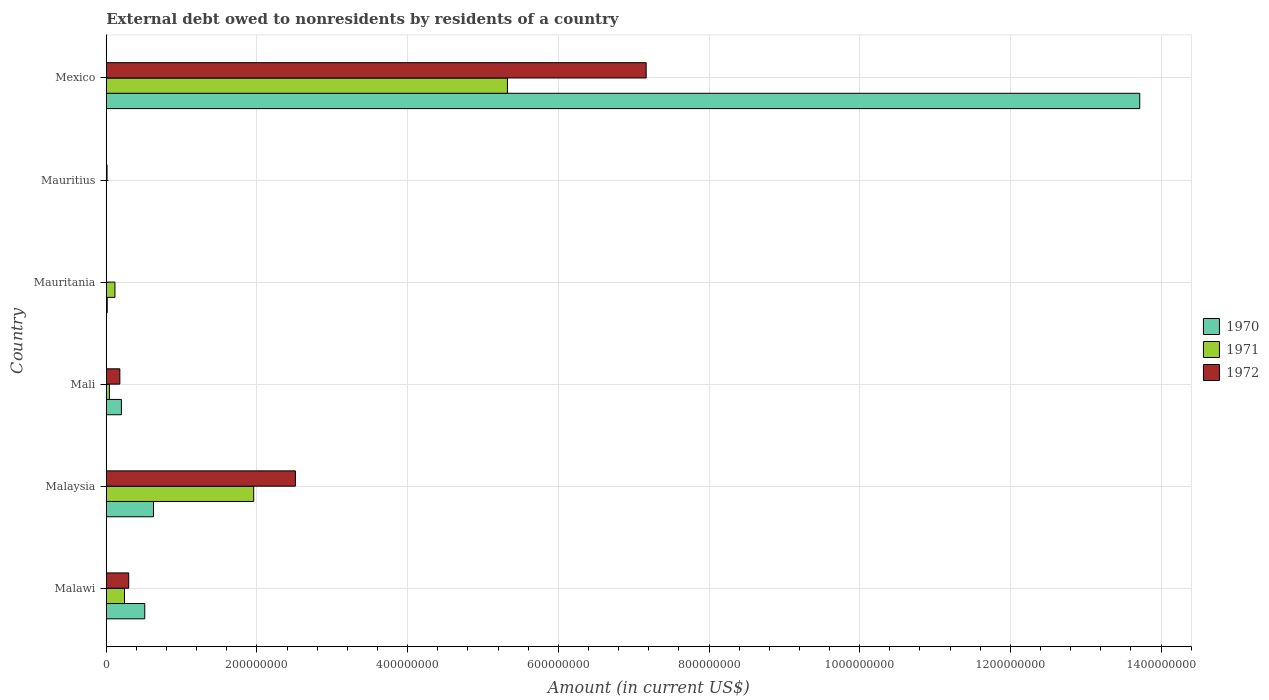How many different coloured bars are there?
Offer a terse response. 3. Are the number of bars per tick equal to the number of legend labels?
Offer a very short reply. No. How many bars are there on the 5th tick from the bottom?
Offer a terse response. 1. What is the label of the 6th group of bars from the top?
Your answer should be very brief. Malawi. In how many cases, is the number of bars for a given country not equal to the number of legend labels?
Make the answer very short. 2. What is the external debt owed by residents in 1970 in Mexico?
Provide a short and direct response. 1.37e+09. Across all countries, what is the maximum external debt owed by residents in 1970?
Your response must be concise. 1.37e+09. Across all countries, what is the minimum external debt owed by residents in 1970?
Provide a short and direct response. 0. What is the total external debt owed by residents in 1971 in the graph?
Give a very brief answer. 7.68e+08. What is the difference between the external debt owed by residents in 1970 in Mauritania and that in Mexico?
Ensure brevity in your answer.  -1.37e+09. What is the difference between the external debt owed by residents in 1972 in Malaysia and the external debt owed by residents in 1971 in Mauritania?
Your answer should be very brief. 2.40e+08. What is the average external debt owed by residents in 1972 per country?
Provide a succinct answer. 1.69e+08. What is the difference between the external debt owed by residents in 1971 and external debt owed by residents in 1972 in Mali?
Give a very brief answer. -1.38e+07. What is the ratio of the external debt owed by residents in 1970 in Malawi to that in Mauritania?
Make the answer very short. 38.24. Is the external debt owed by residents in 1971 in Malawi less than that in Mexico?
Offer a terse response. Yes. Is the difference between the external debt owed by residents in 1971 in Malawi and Mexico greater than the difference between the external debt owed by residents in 1972 in Malawi and Mexico?
Provide a short and direct response. Yes. What is the difference between the highest and the second highest external debt owed by residents in 1972?
Provide a succinct answer. 4.66e+08. What is the difference between the highest and the lowest external debt owed by residents in 1971?
Provide a succinct answer. 5.32e+08. How many bars are there?
Give a very brief answer. 15. Are all the bars in the graph horizontal?
Provide a short and direct response. Yes. What is the difference between two consecutive major ticks on the X-axis?
Your answer should be compact. 2.00e+08. Does the graph contain any zero values?
Offer a terse response. Yes. Does the graph contain grids?
Provide a short and direct response. Yes. Where does the legend appear in the graph?
Offer a terse response. Center right. How many legend labels are there?
Offer a terse response. 3. What is the title of the graph?
Provide a succinct answer. External debt owed to nonresidents by residents of a country. Does "1992" appear as one of the legend labels in the graph?
Your answer should be compact. No. What is the label or title of the X-axis?
Offer a very short reply. Amount (in current US$). What is the label or title of the Y-axis?
Offer a terse response. Country. What is the Amount (in current US$) of 1970 in Malawi?
Provide a succinct answer. 5.11e+07. What is the Amount (in current US$) of 1971 in Malawi?
Your response must be concise. 2.42e+07. What is the Amount (in current US$) in 1972 in Malawi?
Make the answer very short. 2.98e+07. What is the Amount (in current US$) of 1970 in Malaysia?
Provide a succinct answer. 6.28e+07. What is the Amount (in current US$) in 1971 in Malaysia?
Make the answer very short. 1.96e+08. What is the Amount (in current US$) of 1972 in Malaysia?
Provide a short and direct response. 2.51e+08. What is the Amount (in current US$) of 1970 in Mali?
Provide a succinct answer. 2.01e+07. What is the Amount (in current US$) of 1971 in Mali?
Your response must be concise. 4.24e+06. What is the Amount (in current US$) of 1972 in Mali?
Your answer should be very brief. 1.81e+07. What is the Amount (in current US$) of 1970 in Mauritania?
Keep it short and to the point. 1.34e+06. What is the Amount (in current US$) of 1971 in Mauritania?
Ensure brevity in your answer.  1.15e+07. What is the Amount (in current US$) in 1971 in Mauritius?
Provide a succinct answer. 0. What is the Amount (in current US$) in 1972 in Mauritius?
Your answer should be compact. 1.06e+06. What is the Amount (in current US$) of 1970 in Mexico?
Your answer should be very brief. 1.37e+09. What is the Amount (in current US$) in 1971 in Mexico?
Ensure brevity in your answer.  5.32e+08. What is the Amount (in current US$) in 1972 in Mexico?
Give a very brief answer. 7.17e+08. Across all countries, what is the maximum Amount (in current US$) in 1970?
Offer a very short reply. 1.37e+09. Across all countries, what is the maximum Amount (in current US$) in 1971?
Your response must be concise. 5.32e+08. Across all countries, what is the maximum Amount (in current US$) of 1972?
Your answer should be compact. 7.17e+08. Across all countries, what is the minimum Amount (in current US$) of 1971?
Provide a succinct answer. 0. Across all countries, what is the minimum Amount (in current US$) in 1972?
Make the answer very short. 0. What is the total Amount (in current US$) of 1970 in the graph?
Provide a succinct answer. 1.51e+09. What is the total Amount (in current US$) of 1971 in the graph?
Keep it short and to the point. 7.68e+08. What is the total Amount (in current US$) of 1972 in the graph?
Your answer should be compact. 1.02e+09. What is the difference between the Amount (in current US$) of 1970 in Malawi and that in Malaysia?
Provide a short and direct response. -1.16e+07. What is the difference between the Amount (in current US$) in 1971 in Malawi and that in Malaysia?
Give a very brief answer. -1.72e+08. What is the difference between the Amount (in current US$) of 1972 in Malawi and that in Malaysia?
Your response must be concise. -2.21e+08. What is the difference between the Amount (in current US$) of 1970 in Malawi and that in Mali?
Your response must be concise. 3.10e+07. What is the difference between the Amount (in current US$) in 1971 in Malawi and that in Mali?
Keep it short and to the point. 2.00e+07. What is the difference between the Amount (in current US$) in 1972 in Malawi and that in Mali?
Your answer should be compact. 1.18e+07. What is the difference between the Amount (in current US$) of 1970 in Malawi and that in Mauritania?
Provide a succinct answer. 4.98e+07. What is the difference between the Amount (in current US$) of 1971 in Malawi and that in Mauritania?
Ensure brevity in your answer.  1.27e+07. What is the difference between the Amount (in current US$) of 1972 in Malawi and that in Mauritius?
Your answer should be very brief. 2.88e+07. What is the difference between the Amount (in current US$) in 1970 in Malawi and that in Mexico?
Offer a terse response. -1.32e+09. What is the difference between the Amount (in current US$) in 1971 in Malawi and that in Mexico?
Your answer should be very brief. -5.08e+08. What is the difference between the Amount (in current US$) in 1972 in Malawi and that in Mexico?
Provide a short and direct response. -6.87e+08. What is the difference between the Amount (in current US$) of 1970 in Malaysia and that in Mali?
Offer a terse response. 4.26e+07. What is the difference between the Amount (in current US$) of 1971 in Malaysia and that in Mali?
Your response must be concise. 1.91e+08. What is the difference between the Amount (in current US$) of 1972 in Malaysia and that in Mali?
Provide a succinct answer. 2.33e+08. What is the difference between the Amount (in current US$) in 1970 in Malaysia and that in Mauritania?
Offer a very short reply. 6.14e+07. What is the difference between the Amount (in current US$) in 1971 in Malaysia and that in Mauritania?
Offer a terse response. 1.84e+08. What is the difference between the Amount (in current US$) of 1972 in Malaysia and that in Mauritius?
Provide a succinct answer. 2.50e+08. What is the difference between the Amount (in current US$) in 1970 in Malaysia and that in Mexico?
Keep it short and to the point. -1.31e+09. What is the difference between the Amount (in current US$) of 1971 in Malaysia and that in Mexico?
Offer a very short reply. -3.37e+08. What is the difference between the Amount (in current US$) of 1972 in Malaysia and that in Mexico?
Give a very brief answer. -4.66e+08. What is the difference between the Amount (in current US$) of 1970 in Mali and that in Mauritania?
Offer a very short reply. 1.88e+07. What is the difference between the Amount (in current US$) in 1971 in Mali and that in Mauritania?
Give a very brief answer. -7.31e+06. What is the difference between the Amount (in current US$) of 1972 in Mali and that in Mauritius?
Your answer should be compact. 1.70e+07. What is the difference between the Amount (in current US$) in 1970 in Mali and that in Mexico?
Offer a terse response. -1.35e+09. What is the difference between the Amount (in current US$) in 1971 in Mali and that in Mexico?
Your response must be concise. -5.28e+08. What is the difference between the Amount (in current US$) in 1972 in Mali and that in Mexico?
Make the answer very short. -6.99e+08. What is the difference between the Amount (in current US$) of 1970 in Mauritania and that in Mexico?
Keep it short and to the point. -1.37e+09. What is the difference between the Amount (in current US$) in 1971 in Mauritania and that in Mexico?
Give a very brief answer. -5.21e+08. What is the difference between the Amount (in current US$) of 1972 in Mauritius and that in Mexico?
Your response must be concise. -7.16e+08. What is the difference between the Amount (in current US$) in 1970 in Malawi and the Amount (in current US$) in 1971 in Malaysia?
Keep it short and to the point. -1.45e+08. What is the difference between the Amount (in current US$) of 1970 in Malawi and the Amount (in current US$) of 1972 in Malaysia?
Offer a terse response. -2.00e+08. What is the difference between the Amount (in current US$) in 1971 in Malawi and the Amount (in current US$) in 1972 in Malaysia?
Provide a short and direct response. -2.27e+08. What is the difference between the Amount (in current US$) in 1970 in Malawi and the Amount (in current US$) in 1971 in Mali?
Offer a terse response. 4.69e+07. What is the difference between the Amount (in current US$) of 1970 in Malawi and the Amount (in current US$) of 1972 in Mali?
Make the answer very short. 3.31e+07. What is the difference between the Amount (in current US$) in 1971 in Malawi and the Amount (in current US$) in 1972 in Mali?
Your answer should be very brief. 6.17e+06. What is the difference between the Amount (in current US$) in 1970 in Malawi and the Amount (in current US$) in 1971 in Mauritania?
Your answer should be compact. 3.96e+07. What is the difference between the Amount (in current US$) of 1970 in Malawi and the Amount (in current US$) of 1972 in Mauritius?
Your answer should be very brief. 5.01e+07. What is the difference between the Amount (in current US$) of 1971 in Malawi and the Amount (in current US$) of 1972 in Mauritius?
Offer a terse response. 2.32e+07. What is the difference between the Amount (in current US$) of 1970 in Malawi and the Amount (in current US$) of 1971 in Mexico?
Your answer should be very brief. -4.81e+08. What is the difference between the Amount (in current US$) in 1970 in Malawi and the Amount (in current US$) in 1972 in Mexico?
Offer a terse response. -6.65e+08. What is the difference between the Amount (in current US$) of 1971 in Malawi and the Amount (in current US$) of 1972 in Mexico?
Provide a succinct answer. -6.92e+08. What is the difference between the Amount (in current US$) of 1970 in Malaysia and the Amount (in current US$) of 1971 in Mali?
Your response must be concise. 5.85e+07. What is the difference between the Amount (in current US$) in 1970 in Malaysia and the Amount (in current US$) in 1972 in Mali?
Give a very brief answer. 4.47e+07. What is the difference between the Amount (in current US$) of 1971 in Malaysia and the Amount (in current US$) of 1972 in Mali?
Make the answer very short. 1.78e+08. What is the difference between the Amount (in current US$) of 1970 in Malaysia and the Amount (in current US$) of 1971 in Mauritania?
Your response must be concise. 5.12e+07. What is the difference between the Amount (in current US$) of 1970 in Malaysia and the Amount (in current US$) of 1972 in Mauritius?
Your answer should be very brief. 6.17e+07. What is the difference between the Amount (in current US$) of 1971 in Malaysia and the Amount (in current US$) of 1972 in Mauritius?
Make the answer very short. 1.95e+08. What is the difference between the Amount (in current US$) in 1970 in Malaysia and the Amount (in current US$) in 1971 in Mexico?
Your answer should be compact. -4.70e+08. What is the difference between the Amount (in current US$) in 1970 in Malaysia and the Amount (in current US$) in 1972 in Mexico?
Offer a terse response. -6.54e+08. What is the difference between the Amount (in current US$) in 1971 in Malaysia and the Amount (in current US$) in 1972 in Mexico?
Your answer should be very brief. -5.21e+08. What is the difference between the Amount (in current US$) of 1970 in Mali and the Amount (in current US$) of 1971 in Mauritania?
Your response must be concise. 8.58e+06. What is the difference between the Amount (in current US$) of 1970 in Mali and the Amount (in current US$) of 1972 in Mauritius?
Ensure brevity in your answer.  1.91e+07. What is the difference between the Amount (in current US$) in 1971 in Mali and the Amount (in current US$) in 1972 in Mauritius?
Ensure brevity in your answer.  3.18e+06. What is the difference between the Amount (in current US$) of 1970 in Mali and the Amount (in current US$) of 1971 in Mexico?
Keep it short and to the point. -5.12e+08. What is the difference between the Amount (in current US$) of 1970 in Mali and the Amount (in current US$) of 1972 in Mexico?
Provide a short and direct response. -6.96e+08. What is the difference between the Amount (in current US$) of 1971 in Mali and the Amount (in current US$) of 1972 in Mexico?
Your answer should be very brief. -7.12e+08. What is the difference between the Amount (in current US$) of 1970 in Mauritania and the Amount (in current US$) of 1972 in Mauritius?
Your response must be concise. 2.82e+05. What is the difference between the Amount (in current US$) in 1971 in Mauritania and the Amount (in current US$) in 1972 in Mauritius?
Provide a succinct answer. 1.05e+07. What is the difference between the Amount (in current US$) in 1970 in Mauritania and the Amount (in current US$) in 1971 in Mexico?
Provide a short and direct response. -5.31e+08. What is the difference between the Amount (in current US$) of 1970 in Mauritania and the Amount (in current US$) of 1972 in Mexico?
Your response must be concise. -7.15e+08. What is the difference between the Amount (in current US$) of 1971 in Mauritania and the Amount (in current US$) of 1972 in Mexico?
Keep it short and to the point. -7.05e+08. What is the average Amount (in current US$) in 1970 per country?
Your response must be concise. 2.51e+08. What is the average Amount (in current US$) in 1971 per country?
Provide a succinct answer. 1.28e+08. What is the average Amount (in current US$) of 1972 per country?
Offer a very short reply. 1.69e+08. What is the difference between the Amount (in current US$) of 1970 and Amount (in current US$) of 1971 in Malawi?
Provide a short and direct response. 2.69e+07. What is the difference between the Amount (in current US$) in 1970 and Amount (in current US$) in 1972 in Malawi?
Ensure brevity in your answer.  2.13e+07. What is the difference between the Amount (in current US$) in 1971 and Amount (in current US$) in 1972 in Malawi?
Give a very brief answer. -5.59e+06. What is the difference between the Amount (in current US$) in 1970 and Amount (in current US$) in 1971 in Malaysia?
Offer a terse response. -1.33e+08. What is the difference between the Amount (in current US$) of 1970 and Amount (in current US$) of 1972 in Malaysia?
Provide a succinct answer. -1.88e+08. What is the difference between the Amount (in current US$) in 1971 and Amount (in current US$) in 1972 in Malaysia?
Keep it short and to the point. -5.53e+07. What is the difference between the Amount (in current US$) of 1970 and Amount (in current US$) of 1971 in Mali?
Offer a terse response. 1.59e+07. What is the difference between the Amount (in current US$) of 1970 and Amount (in current US$) of 1972 in Mali?
Your answer should be very brief. 2.07e+06. What is the difference between the Amount (in current US$) of 1971 and Amount (in current US$) of 1972 in Mali?
Ensure brevity in your answer.  -1.38e+07. What is the difference between the Amount (in current US$) of 1970 and Amount (in current US$) of 1971 in Mauritania?
Keep it short and to the point. -1.02e+07. What is the difference between the Amount (in current US$) of 1970 and Amount (in current US$) of 1971 in Mexico?
Your answer should be compact. 8.39e+08. What is the difference between the Amount (in current US$) in 1970 and Amount (in current US$) in 1972 in Mexico?
Provide a short and direct response. 6.55e+08. What is the difference between the Amount (in current US$) in 1971 and Amount (in current US$) in 1972 in Mexico?
Provide a short and direct response. -1.84e+08. What is the ratio of the Amount (in current US$) of 1970 in Malawi to that in Malaysia?
Make the answer very short. 0.81. What is the ratio of the Amount (in current US$) in 1971 in Malawi to that in Malaysia?
Your answer should be compact. 0.12. What is the ratio of the Amount (in current US$) of 1972 in Malawi to that in Malaysia?
Your answer should be compact. 0.12. What is the ratio of the Amount (in current US$) of 1970 in Malawi to that in Mali?
Your answer should be very brief. 2.54. What is the ratio of the Amount (in current US$) of 1971 in Malawi to that in Mali?
Provide a short and direct response. 5.72. What is the ratio of the Amount (in current US$) in 1972 in Malawi to that in Mali?
Provide a short and direct response. 1.65. What is the ratio of the Amount (in current US$) of 1970 in Malawi to that in Mauritania?
Make the answer very short. 38.24. What is the ratio of the Amount (in current US$) in 1971 in Malawi to that in Mauritania?
Ensure brevity in your answer.  2.1. What is the ratio of the Amount (in current US$) of 1972 in Malawi to that in Mauritius?
Give a very brief answer. 28.26. What is the ratio of the Amount (in current US$) in 1970 in Malawi to that in Mexico?
Make the answer very short. 0.04. What is the ratio of the Amount (in current US$) in 1971 in Malawi to that in Mexico?
Keep it short and to the point. 0.05. What is the ratio of the Amount (in current US$) of 1972 in Malawi to that in Mexico?
Provide a succinct answer. 0.04. What is the ratio of the Amount (in current US$) in 1970 in Malaysia to that in Mali?
Your answer should be very brief. 3.12. What is the ratio of the Amount (in current US$) in 1971 in Malaysia to that in Mali?
Give a very brief answer. 46.21. What is the ratio of the Amount (in current US$) in 1972 in Malaysia to that in Mali?
Your answer should be compact. 13.9. What is the ratio of the Amount (in current US$) of 1970 in Malaysia to that in Mauritania?
Provide a short and direct response. 46.94. What is the ratio of the Amount (in current US$) in 1971 in Malaysia to that in Mauritania?
Offer a very short reply. 16.96. What is the ratio of the Amount (in current US$) in 1972 in Malaysia to that in Mauritius?
Offer a very short reply. 237.98. What is the ratio of the Amount (in current US$) in 1970 in Malaysia to that in Mexico?
Your answer should be compact. 0.05. What is the ratio of the Amount (in current US$) in 1971 in Malaysia to that in Mexico?
Give a very brief answer. 0.37. What is the ratio of the Amount (in current US$) in 1972 in Malaysia to that in Mexico?
Offer a terse response. 0.35. What is the ratio of the Amount (in current US$) of 1970 in Mali to that in Mauritania?
Make the answer very short. 15.05. What is the ratio of the Amount (in current US$) in 1971 in Mali to that in Mauritania?
Your response must be concise. 0.37. What is the ratio of the Amount (in current US$) of 1972 in Mali to that in Mauritius?
Make the answer very short. 17.11. What is the ratio of the Amount (in current US$) of 1970 in Mali to that in Mexico?
Ensure brevity in your answer.  0.01. What is the ratio of the Amount (in current US$) in 1971 in Mali to that in Mexico?
Make the answer very short. 0.01. What is the ratio of the Amount (in current US$) in 1972 in Mali to that in Mexico?
Your answer should be compact. 0.03. What is the ratio of the Amount (in current US$) of 1971 in Mauritania to that in Mexico?
Give a very brief answer. 0.02. What is the ratio of the Amount (in current US$) in 1972 in Mauritius to that in Mexico?
Keep it short and to the point. 0. What is the difference between the highest and the second highest Amount (in current US$) in 1970?
Offer a terse response. 1.31e+09. What is the difference between the highest and the second highest Amount (in current US$) in 1971?
Keep it short and to the point. 3.37e+08. What is the difference between the highest and the second highest Amount (in current US$) in 1972?
Provide a short and direct response. 4.66e+08. What is the difference between the highest and the lowest Amount (in current US$) of 1970?
Offer a terse response. 1.37e+09. What is the difference between the highest and the lowest Amount (in current US$) in 1971?
Provide a succinct answer. 5.32e+08. What is the difference between the highest and the lowest Amount (in current US$) of 1972?
Provide a short and direct response. 7.17e+08. 